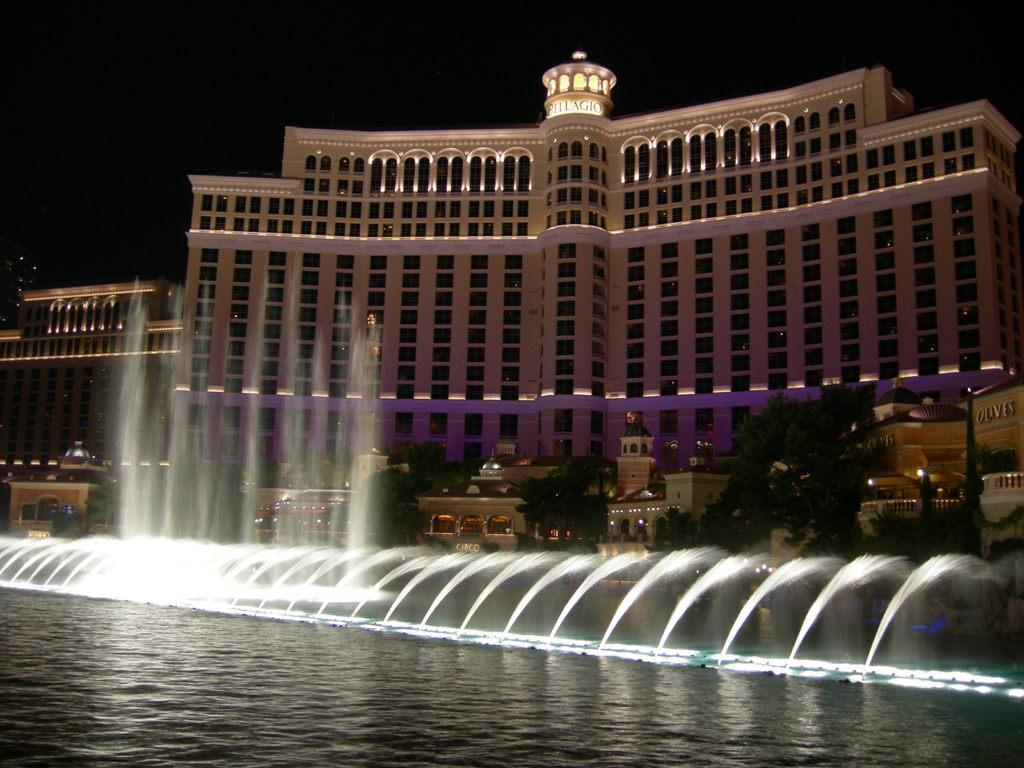What is the main subject in the foreground of the image? There is a water fountain in the foreground of the image. What can be seen in the background of the image? There is a group of trees and a building in the background of the image. What is visible above the trees and building in the image? The sky is visible in the background of the image. What color is the lake in the image? There is no lake present in the image. 